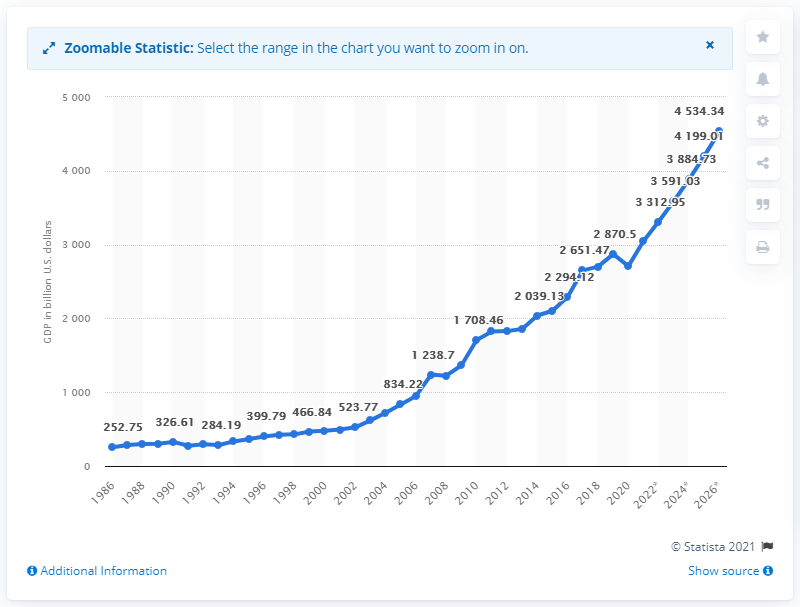Point out several critical features in this image. What is the difference between each consecutive y-axis tick from 1000? As of 2020, India's GDP has finally come to an end. In 2019, the Gross Domestic Product (GDP) of India was approximately 2870.5 billion dollars. 